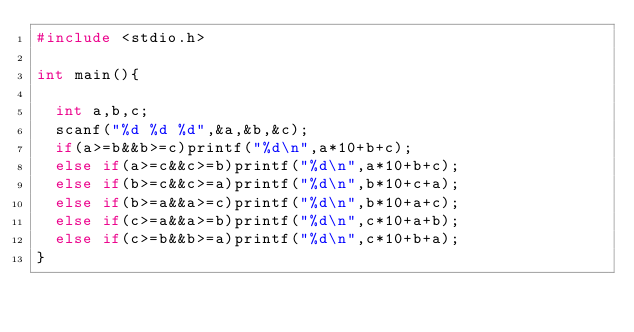Convert code to text. <code><loc_0><loc_0><loc_500><loc_500><_C_>#include <stdio.h>

int main(){
	
	int a,b,c;
	scanf("%d %d %d",&a,&b,&c);
	if(a>=b&&b>=c)printf("%d\n",a*10+b+c);
	else if(a>=c&&c>=b)printf("%d\n",a*10+b+c);
	else if(b>=c&&c>=a)printf("%d\n",b*10+c+a);
	else if(b>=a&&a>=c)printf("%d\n",b*10+a+c);
	else if(c>=a&&a>=b)printf("%d\n",c*10+a+b);
	else if(c>=b&&b>=a)printf("%d\n",c*10+b+a);
}
</code> 